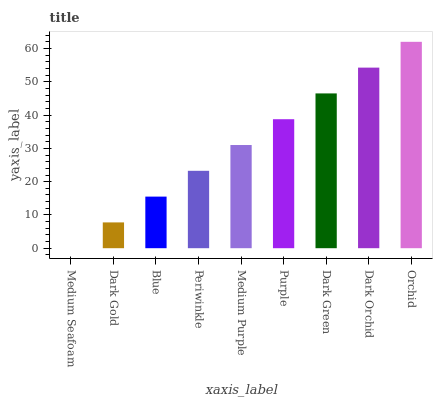Is Medium Seafoam the minimum?
Answer yes or no. Yes. Is Orchid the maximum?
Answer yes or no. Yes. Is Dark Gold the minimum?
Answer yes or no. No. Is Dark Gold the maximum?
Answer yes or no. No. Is Dark Gold greater than Medium Seafoam?
Answer yes or no. Yes. Is Medium Seafoam less than Dark Gold?
Answer yes or no. Yes. Is Medium Seafoam greater than Dark Gold?
Answer yes or no. No. Is Dark Gold less than Medium Seafoam?
Answer yes or no. No. Is Medium Purple the high median?
Answer yes or no. Yes. Is Medium Purple the low median?
Answer yes or no. Yes. Is Dark Gold the high median?
Answer yes or no. No. Is Dark Gold the low median?
Answer yes or no. No. 